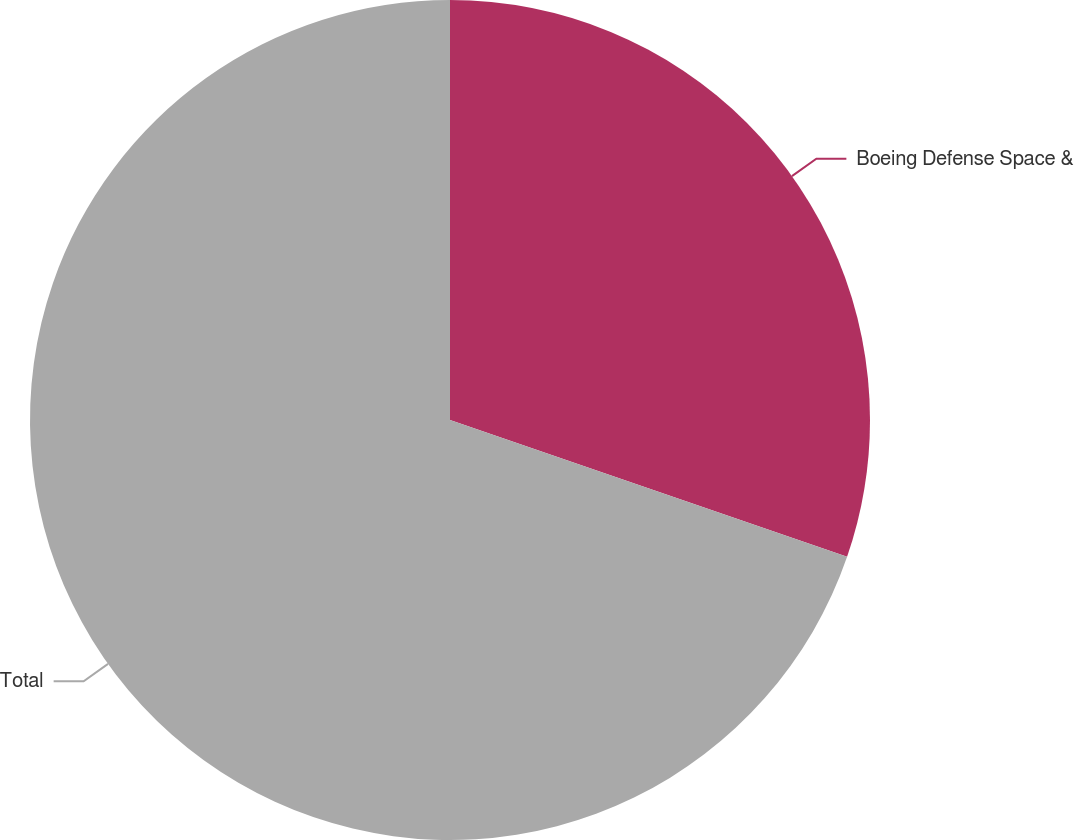<chart> <loc_0><loc_0><loc_500><loc_500><pie_chart><fcel>Boeing Defense Space &<fcel>Total<nl><fcel>30.28%<fcel>69.72%<nl></chart> 